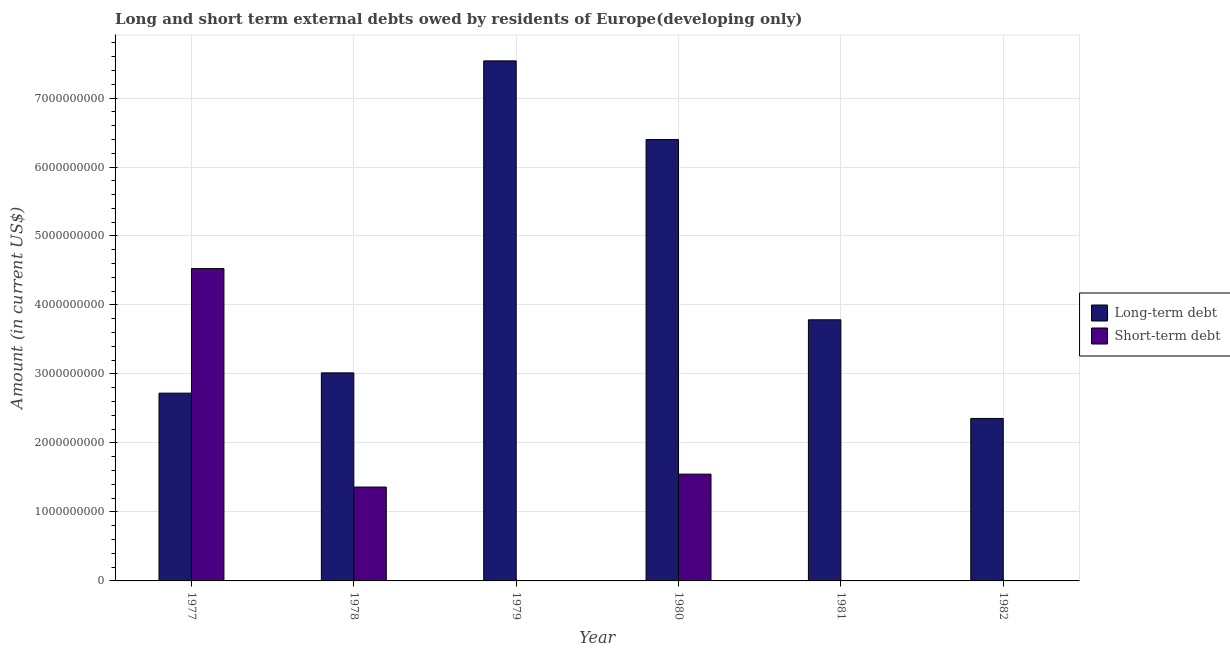Are the number of bars on each tick of the X-axis equal?
Make the answer very short. No. How many bars are there on the 4th tick from the right?
Provide a succinct answer. 1. What is the label of the 2nd group of bars from the left?
Keep it short and to the point. 1978. What is the short-term debts owed by residents in 1982?
Your answer should be compact. 0. Across all years, what is the maximum short-term debts owed by residents?
Keep it short and to the point. 4.53e+09. In which year was the short-term debts owed by residents maximum?
Your answer should be compact. 1977. What is the total long-term debts owed by residents in the graph?
Provide a succinct answer. 2.58e+1. What is the difference between the long-term debts owed by residents in 1979 and that in 1981?
Your answer should be very brief. 3.75e+09. What is the difference between the short-term debts owed by residents in 1979 and the long-term debts owed by residents in 1977?
Keep it short and to the point. -4.53e+09. What is the average long-term debts owed by residents per year?
Make the answer very short. 4.30e+09. What is the ratio of the long-term debts owed by residents in 1979 to that in 1981?
Ensure brevity in your answer.  1.99. Is the long-term debts owed by residents in 1979 less than that in 1980?
Offer a very short reply. No. What is the difference between the highest and the second highest short-term debts owed by residents?
Provide a succinct answer. 2.98e+09. What is the difference between the highest and the lowest short-term debts owed by residents?
Ensure brevity in your answer.  4.53e+09. Is the sum of the long-term debts owed by residents in 1981 and 1982 greater than the maximum short-term debts owed by residents across all years?
Your response must be concise. No. How many bars are there?
Your response must be concise. 9. How many years are there in the graph?
Keep it short and to the point. 6. What is the difference between two consecutive major ticks on the Y-axis?
Your answer should be compact. 1.00e+09. Does the graph contain any zero values?
Make the answer very short. Yes. How many legend labels are there?
Your response must be concise. 2. How are the legend labels stacked?
Your answer should be compact. Vertical. What is the title of the graph?
Make the answer very short. Long and short term external debts owed by residents of Europe(developing only). Does "Electricity and heat production" appear as one of the legend labels in the graph?
Keep it short and to the point. No. What is the label or title of the Y-axis?
Your answer should be compact. Amount (in current US$). What is the Amount (in current US$) of Long-term debt in 1977?
Offer a very short reply. 2.72e+09. What is the Amount (in current US$) of Short-term debt in 1977?
Your answer should be compact. 4.53e+09. What is the Amount (in current US$) in Long-term debt in 1978?
Offer a very short reply. 3.02e+09. What is the Amount (in current US$) in Short-term debt in 1978?
Provide a succinct answer. 1.36e+09. What is the Amount (in current US$) in Long-term debt in 1979?
Keep it short and to the point. 7.54e+09. What is the Amount (in current US$) of Short-term debt in 1979?
Your response must be concise. 0. What is the Amount (in current US$) of Long-term debt in 1980?
Your response must be concise. 6.40e+09. What is the Amount (in current US$) in Short-term debt in 1980?
Provide a short and direct response. 1.55e+09. What is the Amount (in current US$) of Long-term debt in 1981?
Provide a succinct answer. 3.79e+09. What is the Amount (in current US$) of Long-term debt in 1982?
Your answer should be compact. 2.36e+09. Across all years, what is the maximum Amount (in current US$) of Long-term debt?
Your answer should be compact. 7.54e+09. Across all years, what is the maximum Amount (in current US$) of Short-term debt?
Provide a short and direct response. 4.53e+09. Across all years, what is the minimum Amount (in current US$) of Long-term debt?
Ensure brevity in your answer.  2.36e+09. What is the total Amount (in current US$) in Long-term debt in the graph?
Offer a terse response. 2.58e+1. What is the total Amount (in current US$) in Short-term debt in the graph?
Your answer should be very brief. 7.44e+09. What is the difference between the Amount (in current US$) of Long-term debt in 1977 and that in 1978?
Your answer should be very brief. -2.94e+08. What is the difference between the Amount (in current US$) of Short-term debt in 1977 and that in 1978?
Give a very brief answer. 3.17e+09. What is the difference between the Amount (in current US$) of Long-term debt in 1977 and that in 1979?
Provide a succinct answer. -4.82e+09. What is the difference between the Amount (in current US$) of Long-term debt in 1977 and that in 1980?
Ensure brevity in your answer.  -3.68e+09. What is the difference between the Amount (in current US$) of Short-term debt in 1977 and that in 1980?
Offer a very short reply. 2.98e+09. What is the difference between the Amount (in current US$) of Long-term debt in 1977 and that in 1981?
Give a very brief answer. -1.06e+09. What is the difference between the Amount (in current US$) in Long-term debt in 1977 and that in 1982?
Ensure brevity in your answer.  3.67e+08. What is the difference between the Amount (in current US$) in Long-term debt in 1978 and that in 1979?
Provide a succinct answer. -4.52e+09. What is the difference between the Amount (in current US$) in Long-term debt in 1978 and that in 1980?
Offer a very short reply. -3.38e+09. What is the difference between the Amount (in current US$) in Short-term debt in 1978 and that in 1980?
Your answer should be very brief. -1.87e+08. What is the difference between the Amount (in current US$) in Long-term debt in 1978 and that in 1981?
Offer a very short reply. -7.69e+08. What is the difference between the Amount (in current US$) of Long-term debt in 1978 and that in 1982?
Your response must be concise. 6.60e+08. What is the difference between the Amount (in current US$) in Long-term debt in 1979 and that in 1980?
Keep it short and to the point. 1.14e+09. What is the difference between the Amount (in current US$) in Long-term debt in 1979 and that in 1981?
Provide a short and direct response. 3.75e+09. What is the difference between the Amount (in current US$) of Long-term debt in 1979 and that in 1982?
Your answer should be very brief. 5.18e+09. What is the difference between the Amount (in current US$) of Long-term debt in 1980 and that in 1981?
Make the answer very short. 2.61e+09. What is the difference between the Amount (in current US$) in Long-term debt in 1980 and that in 1982?
Provide a short and direct response. 4.04e+09. What is the difference between the Amount (in current US$) in Long-term debt in 1981 and that in 1982?
Provide a succinct answer. 1.43e+09. What is the difference between the Amount (in current US$) in Long-term debt in 1977 and the Amount (in current US$) in Short-term debt in 1978?
Offer a very short reply. 1.36e+09. What is the difference between the Amount (in current US$) in Long-term debt in 1977 and the Amount (in current US$) in Short-term debt in 1980?
Provide a short and direct response. 1.17e+09. What is the difference between the Amount (in current US$) in Long-term debt in 1978 and the Amount (in current US$) in Short-term debt in 1980?
Offer a terse response. 1.47e+09. What is the difference between the Amount (in current US$) in Long-term debt in 1979 and the Amount (in current US$) in Short-term debt in 1980?
Provide a short and direct response. 5.99e+09. What is the average Amount (in current US$) in Long-term debt per year?
Provide a short and direct response. 4.30e+09. What is the average Amount (in current US$) in Short-term debt per year?
Your response must be concise. 1.24e+09. In the year 1977, what is the difference between the Amount (in current US$) of Long-term debt and Amount (in current US$) of Short-term debt?
Offer a very short reply. -1.81e+09. In the year 1978, what is the difference between the Amount (in current US$) in Long-term debt and Amount (in current US$) in Short-term debt?
Give a very brief answer. 1.65e+09. In the year 1980, what is the difference between the Amount (in current US$) in Long-term debt and Amount (in current US$) in Short-term debt?
Keep it short and to the point. 4.85e+09. What is the ratio of the Amount (in current US$) of Long-term debt in 1977 to that in 1978?
Provide a succinct answer. 0.9. What is the ratio of the Amount (in current US$) in Short-term debt in 1977 to that in 1978?
Keep it short and to the point. 3.33. What is the ratio of the Amount (in current US$) in Long-term debt in 1977 to that in 1979?
Your response must be concise. 0.36. What is the ratio of the Amount (in current US$) of Long-term debt in 1977 to that in 1980?
Make the answer very short. 0.43. What is the ratio of the Amount (in current US$) of Short-term debt in 1977 to that in 1980?
Keep it short and to the point. 2.93. What is the ratio of the Amount (in current US$) in Long-term debt in 1977 to that in 1981?
Provide a short and direct response. 0.72. What is the ratio of the Amount (in current US$) in Long-term debt in 1977 to that in 1982?
Your answer should be very brief. 1.16. What is the ratio of the Amount (in current US$) of Long-term debt in 1978 to that in 1979?
Offer a terse response. 0.4. What is the ratio of the Amount (in current US$) of Long-term debt in 1978 to that in 1980?
Offer a terse response. 0.47. What is the ratio of the Amount (in current US$) in Short-term debt in 1978 to that in 1980?
Ensure brevity in your answer.  0.88. What is the ratio of the Amount (in current US$) of Long-term debt in 1978 to that in 1981?
Keep it short and to the point. 0.8. What is the ratio of the Amount (in current US$) in Long-term debt in 1978 to that in 1982?
Keep it short and to the point. 1.28. What is the ratio of the Amount (in current US$) of Long-term debt in 1979 to that in 1980?
Your answer should be very brief. 1.18. What is the ratio of the Amount (in current US$) of Long-term debt in 1979 to that in 1981?
Make the answer very short. 1.99. What is the ratio of the Amount (in current US$) in Long-term debt in 1979 to that in 1982?
Your answer should be very brief. 3.2. What is the ratio of the Amount (in current US$) of Long-term debt in 1980 to that in 1981?
Keep it short and to the point. 1.69. What is the ratio of the Amount (in current US$) of Long-term debt in 1980 to that in 1982?
Give a very brief answer. 2.72. What is the ratio of the Amount (in current US$) of Long-term debt in 1981 to that in 1982?
Provide a short and direct response. 1.61. What is the difference between the highest and the second highest Amount (in current US$) in Long-term debt?
Offer a very short reply. 1.14e+09. What is the difference between the highest and the second highest Amount (in current US$) in Short-term debt?
Keep it short and to the point. 2.98e+09. What is the difference between the highest and the lowest Amount (in current US$) of Long-term debt?
Ensure brevity in your answer.  5.18e+09. What is the difference between the highest and the lowest Amount (in current US$) of Short-term debt?
Offer a very short reply. 4.53e+09. 